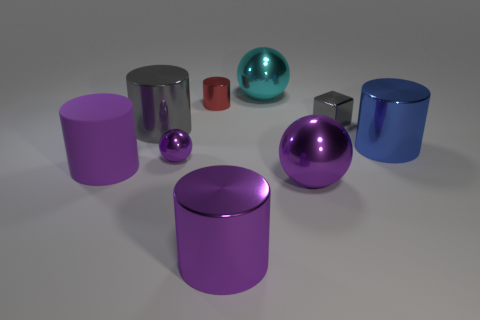Subtract all cyan cylinders. Subtract all gray cubes. How many cylinders are left? 5 Add 1 cylinders. How many objects exist? 10 Subtract all balls. How many objects are left? 6 Add 9 big gray metallic cylinders. How many big gray metallic cylinders are left? 10 Add 9 small cyan shiny blocks. How many small cyan shiny blocks exist? 9 Subtract 0 green cylinders. How many objects are left? 9 Subtract all blocks. Subtract all large purple metallic balls. How many objects are left? 7 